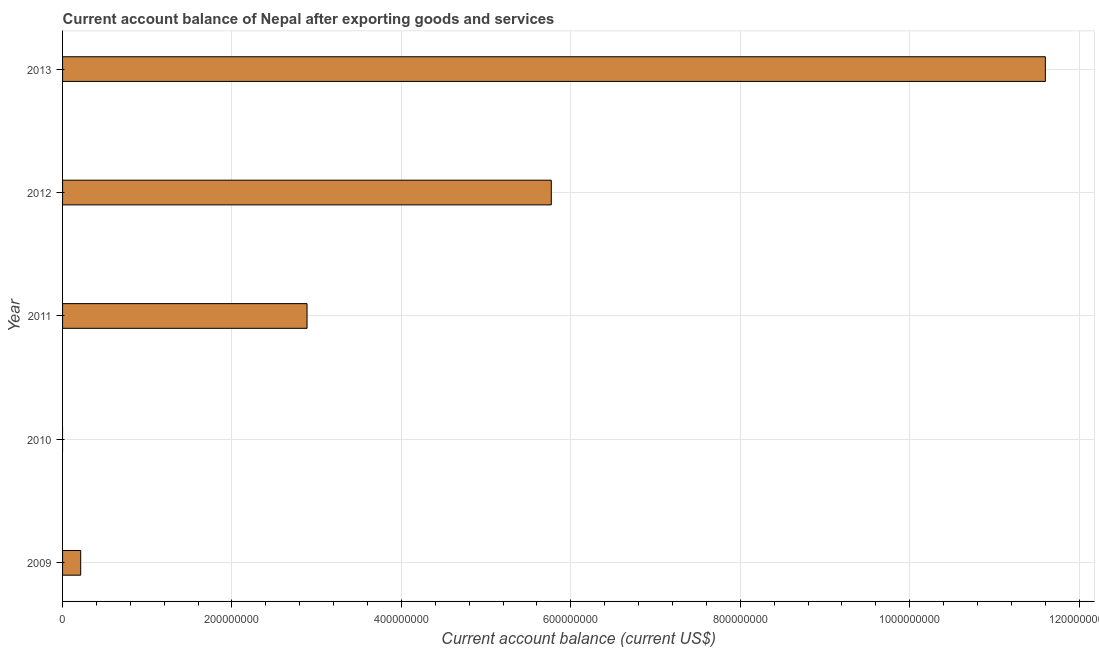What is the title of the graph?
Make the answer very short. Current account balance of Nepal after exporting goods and services. What is the label or title of the X-axis?
Your answer should be compact. Current account balance (current US$). What is the label or title of the Y-axis?
Give a very brief answer. Year. What is the current account balance in 2011?
Offer a very short reply. 2.89e+08. Across all years, what is the maximum current account balance?
Keep it short and to the point. 1.16e+09. In which year was the current account balance maximum?
Your answer should be very brief. 2013. What is the sum of the current account balance?
Your answer should be very brief. 2.05e+09. What is the difference between the current account balance in 2009 and 2011?
Your answer should be very brief. -2.67e+08. What is the average current account balance per year?
Offer a terse response. 4.09e+08. What is the median current account balance?
Keep it short and to the point. 2.89e+08. In how many years, is the current account balance greater than 80000000 US$?
Ensure brevity in your answer.  3. What is the ratio of the current account balance in 2009 to that in 2013?
Your response must be concise. 0.02. Is the current account balance in 2012 less than that in 2013?
Provide a short and direct response. Yes. What is the difference between the highest and the second highest current account balance?
Keep it short and to the point. 5.83e+08. What is the difference between the highest and the lowest current account balance?
Provide a succinct answer. 1.16e+09. In how many years, is the current account balance greater than the average current account balance taken over all years?
Ensure brevity in your answer.  2. How many bars are there?
Your answer should be very brief. 4. How many years are there in the graph?
Provide a short and direct response. 5. What is the difference between two consecutive major ticks on the X-axis?
Ensure brevity in your answer.  2.00e+08. What is the Current account balance (current US$) of 2009?
Give a very brief answer. 2.14e+07. What is the Current account balance (current US$) of 2010?
Offer a very short reply. 0. What is the Current account balance (current US$) in 2011?
Offer a terse response. 2.89e+08. What is the Current account balance (current US$) of 2012?
Keep it short and to the point. 5.77e+08. What is the Current account balance (current US$) in 2013?
Provide a short and direct response. 1.16e+09. What is the difference between the Current account balance (current US$) in 2009 and 2011?
Keep it short and to the point. -2.67e+08. What is the difference between the Current account balance (current US$) in 2009 and 2012?
Make the answer very short. -5.56e+08. What is the difference between the Current account balance (current US$) in 2009 and 2013?
Provide a succinct answer. -1.14e+09. What is the difference between the Current account balance (current US$) in 2011 and 2012?
Keep it short and to the point. -2.88e+08. What is the difference between the Current account balance (current US$) in 2011 and 2013?
Offer a terse response. -8.72e+08. What is the difference between the Current account balance (current US$) in 2012 and 2013?
Make the answer very short. -5.83e+08. What is the ratio of the Current account balance (current US$) in 2009 to that in 2011?
Your response must be concise. 0.07. What is the ratio of the Current account balance (current US$) in 2009 to that in 2012?
Your answer should be compact. 0.04. What is the ratio of the Current account balance (current US$) in 2009 to that in 2013?
Your response must be concise. 0.02. What is the ratio of the Current account balance (current US$) in 2011 to that in 2013?
Offer a very short reply. 0.25. What is the ratio of the Current account balance (current US$) in 2012 to that in 2013?
Offer a terse response. 0.5. 